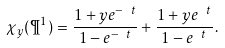Convert formula to latex. <formula><loc_0><loc_0><loc_500><loc_500>\chi _ { y } ( \P ^ { 1 } ) = \frac { 1 + y e ^ { - \ t } } { 1 - e ^ { - \ t } } + \frac { 1 + y e ^ { \ t } } { 1 - e ^ { \ t } } \, .</formula> 